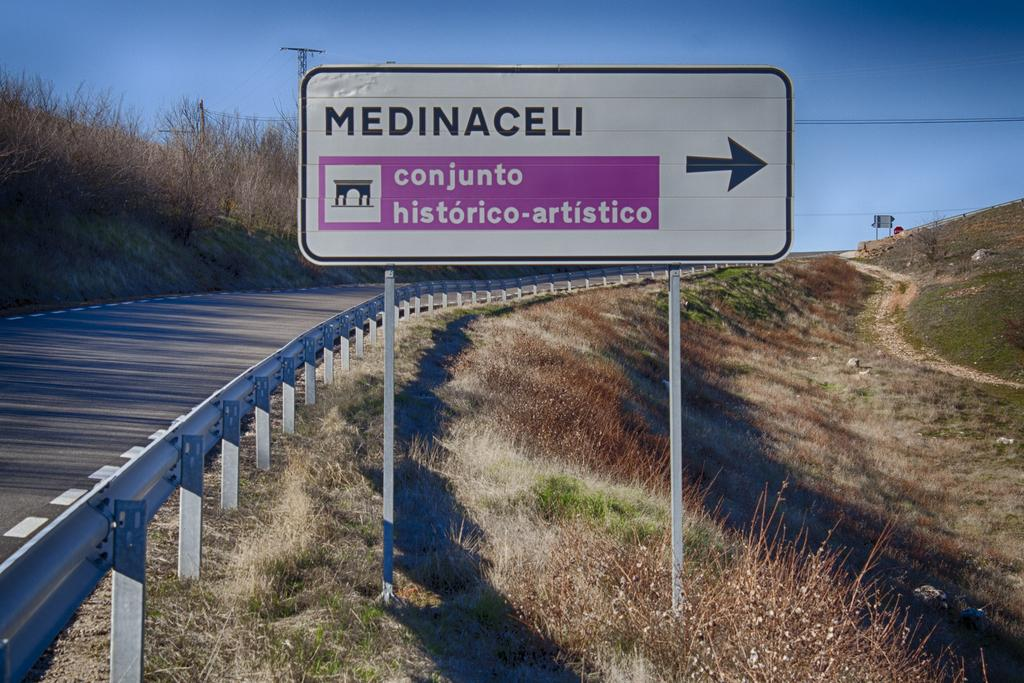<image>
Render a clear and concise summary of the photo. A road sign that says Medinaceli conjunto historico artistico. 